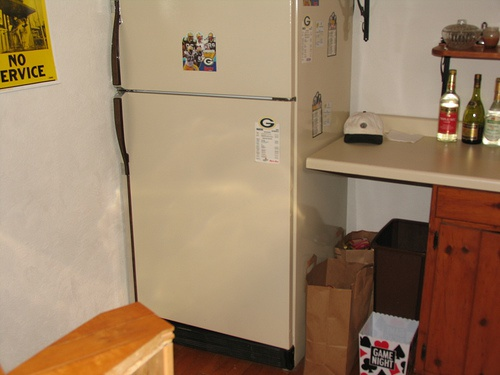Describe the objects in this image and their specific colors. I can see refrigerator in black, tan, and gray tones, bottle in black, olive, and tan tones, bottle in black, brown, khaki, ivory, and olive tones, and bottle in black, tan, olive, and beige tones in this image. 